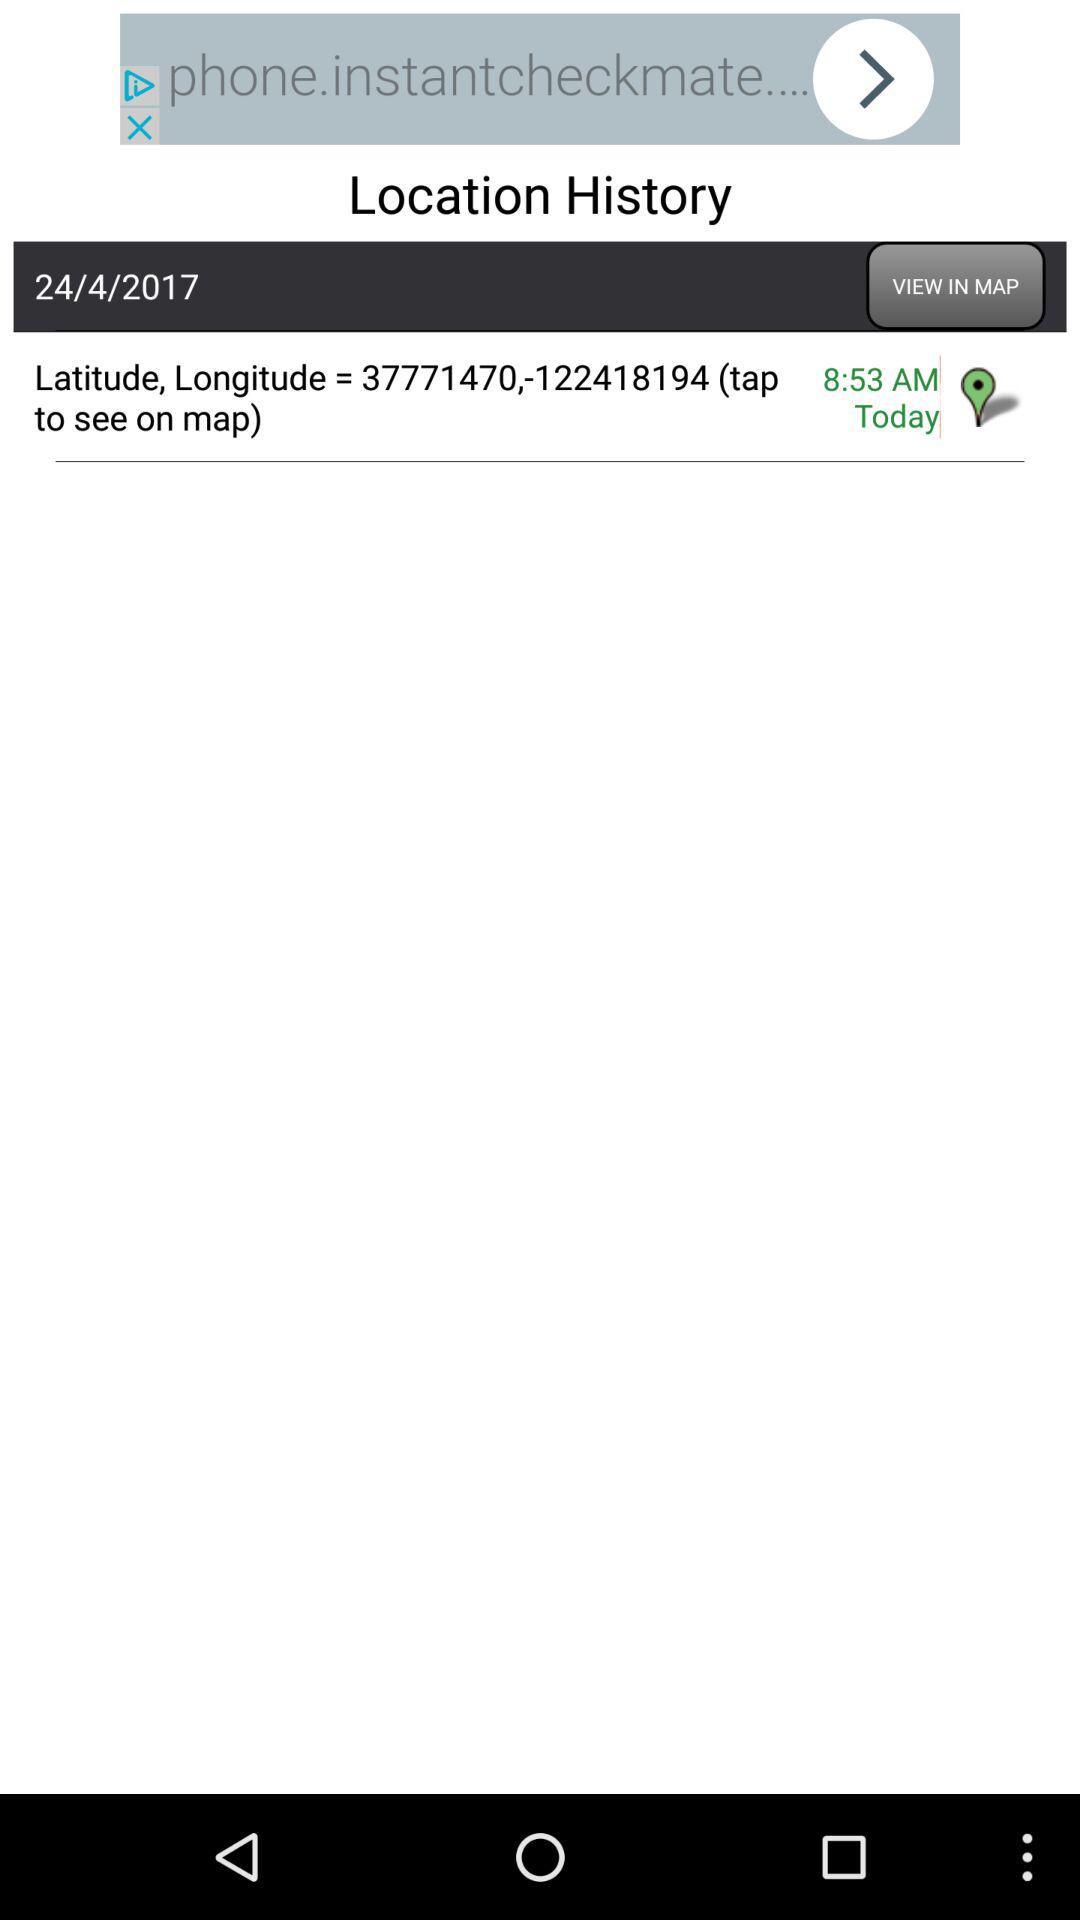When were the longitude and latitude measured? The longitude and latitude were measured at 8:53 a.m. today. 